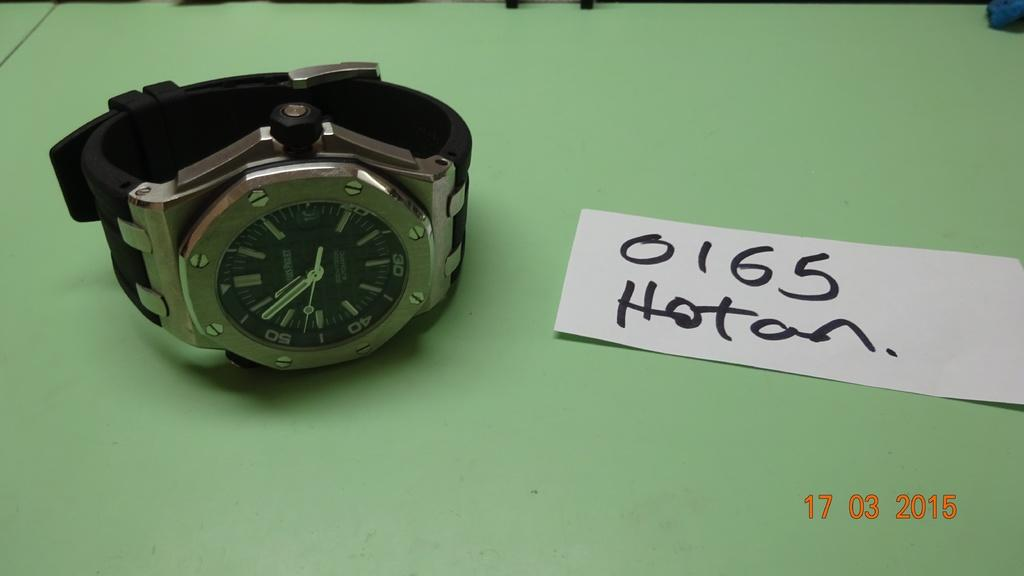<image>
Share a concise interpretation of the image provided. A watch is displayed next to a notecard which reads "0165 Hoton." 